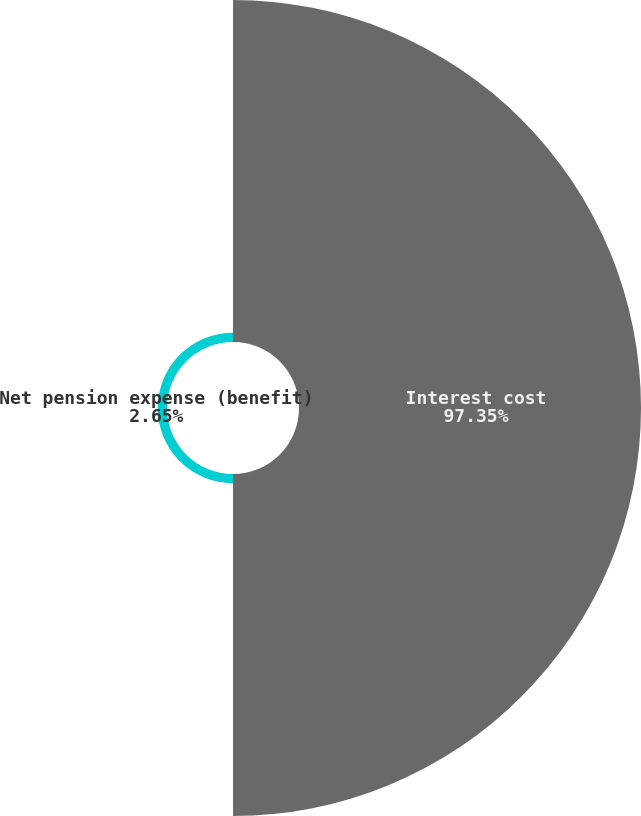<chart> <loc_0><loc_0><loc_500><loc_500><pie_chart><fcel>Interest cost<fcel>Net pension expense (benefit)<nl><fcel>97.35%<fcel>2.65%<nl></chart> 